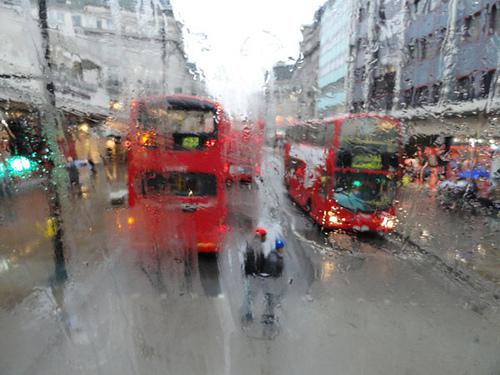Question: where are the people?
Choices:
A. On the couch.
B. In the field.
C. Outside.
D. The street.
Answer with the letter. Answer: D Question: what are the people doing in the street?
Choices:
A. Walking.
B. Dancing.
C. Skipping.
D. Crossing.
Answer with the letter. Answer: D Question: who is in the street?
Choices:
A. Women.
B. A family.
C. Men.
D. Schoolchildren.
Answer with the letter. Answer: C Question: how many men in the street?
Choices:
A. Three.
B. Five.
C. Two.
D. Four.
Answer with the letter. Answer: C Question: what color are the buses?
Choices:
A. Yellow.
B. Orange.
C. Red.
D. Green.
Answer with the letter. Answer: C Question: why is it wet?
Choices:
A. The glass spilled.
B. The water is flowing.
C. The rain.
D. The dryer is broken.
Answer with the letter. Answer: C 